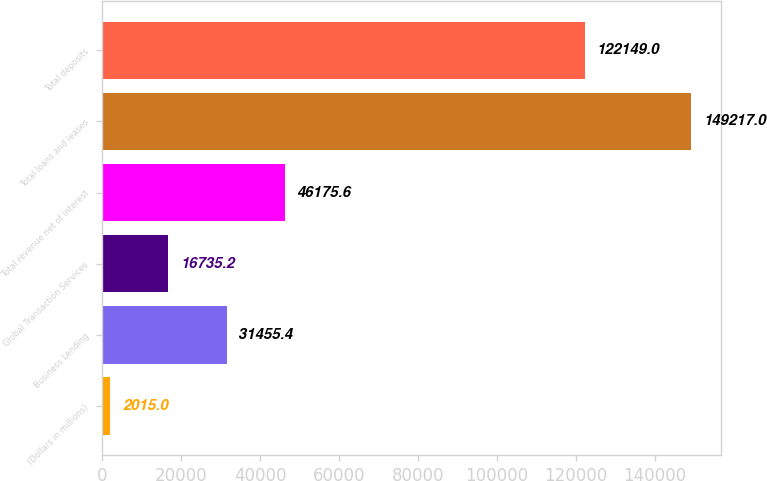Convert chart to OTSL. <chart><loc_0><loc_0><loc_500><loc_500><bar_chart><fcel>(Dollars in millions)<fcel>Business Lending<fcel>Global Transaction Services<fcel>Total revenue net of interest<fcel>Total loans and leases<fcel>Total deposits<nl><fcel>2015<fcel>31455.4<fcel>16735.2<fcel>46175.6<fcel>149217<fcel>122149<nl></chart> 